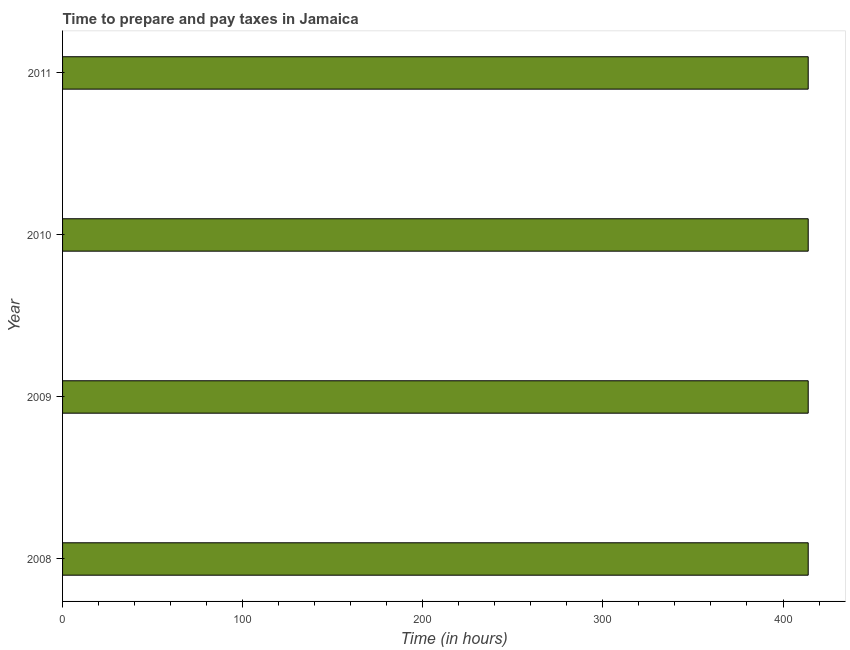Does the graph contain grids?
Make the answer very short. No. What is the title of the graph?
Offer a very short reply. Time to prepare and pay taxes in Jamaica. What is the label or title of the X-axis?
Your answer should be very brief. Time (in hours). What is the time to prepare and pay taxes in 2009?
Offer a terse response. 414. Across all years, what is the maximum time to prepare and pay taxes?
Ensure brevity in your answer.  414. Across all years, what is the minimum time to prepare and pay taxes?
Give a very brief answer. 414. In which year was the time to prepare and pay taxes maximum?
Your answer should be compact. 2008. In which year was the time to prepare and pay taxes minimum?
Offer a very short reply. 2008. What is the sum of the time to prepare and pay taxes?
Provide a succinct answer. 1656. What is the difference between the time to prepare and pay taxes in 2008 and 2009?
Offer a very short reply. 0. What is the average time to prepare and pay taxes per year?
Give a very brief answer. 414. What is the median time to prepare and pay taxes?
Your answer should be compact. 414. In how many years, is the time to prepare and pay taxes greater than 260 hours?
Provide a short and direct response. 4. Do a majority of the years between 2009 and 2011 (inclusive) have time to prepare and pay taxes greater than 180 hours?
Keep it short and to the point. Yes. What is the ratio of the time to prepare and pay taxes in 2010 to that in 2011?
Your answer should be compact. 1. Is the time to prepare and pay taxes in 2010 less than that in 2011?
Offer a very short reply. No. Is the difference between the time to prepare and pay taxes in 2009 and 2011 greater than the difference between any two years?
Offer a terse response. Yes. What is the difference between the highest and the second highest time to prepare and pay taxes?
Offer a terse response. 0. Is the sum of the time to prepare and pay taxes in 2008 and 2010 greater than the maximum time to prepare and pay taxes across all years?
Provide a short and direct response. Yes. How many bars are there?
Your response must be concise. 4. Are all the bars in the graph horizontal?
Offer a very short reply. Yes. How many years are there in the graph?
Offer a very short reply. 4. Are the values on the major ticks of X-axis written in scientific E-notation?
Offer a terse response. No. What is the Time (in hours) in 2008?
Give a very brief answer. 414. What is the Time (in hours) of 2009?
Provide a short and direct response. 414. What is the Time (in hours) of 2010?
Your answer should be compact. 414. What is the Time (in hours) of 2011?
Your answer should be compact. 414. What is the difference between the Time (in hours) in 2008 and 2010?
Offer a very short reply. 0. What is the difference between the Time (in hours) in 2008 and 2011?
Ensure brevity in your answer.  0. What is the difference between the Time (in hours) in 2009 and 2010?
Provide a succinct answer. 0. What is the difference between the Time (in hours) in 2009 and 2011?
Your response must be concise. 0. What is the difference between the Time (in hours) in 2010 and 2011?
Provide a short and direct response. 0. What is the ratio of the Time (in hours) in 2008 to that in 2009?
Your answer should be compact. 1. What is the ratio of the Time (in hours) in 2008 to that in 2010?
Provide a short and direct response. 1. What is the ratio of the Time (in hours) in 2009 to that in 2010?
Provide a succinct answer. 1. What is the ratio of the Time (in hours) in 2010 to that in 2011?
Provide a succinct answer. 1. 